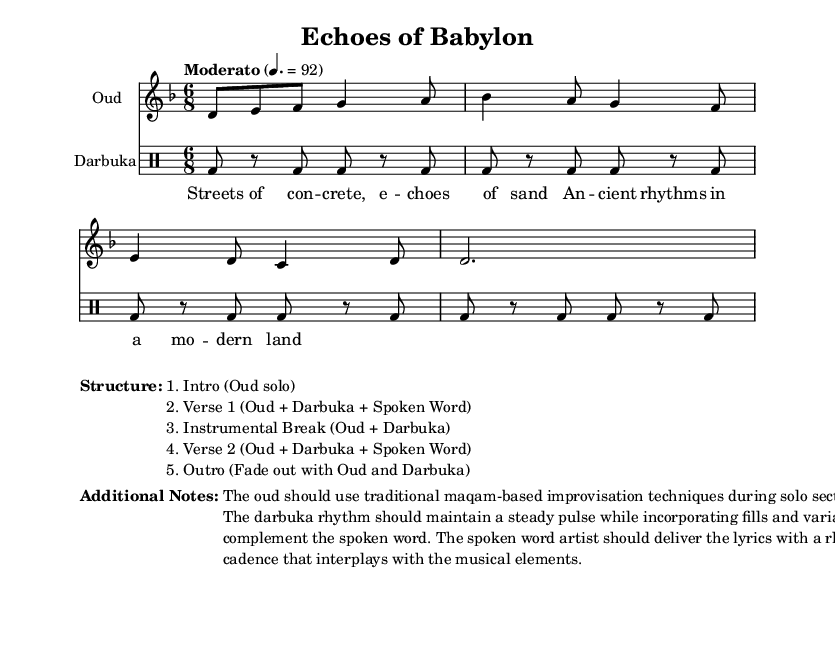What is the key signature of this music? The key signature shows 1 flat, indicating the presence of B flat, which is characteristic of D minor.
Answer: D minor What is the time signature of this music? The time signature is displayed prominently at the beginning of the score, indicating a 6/8 meter.
Answer: 6/8 What is the tempo marking for this piece? The tempo marking is "Moderato," which suggests a moderate pace, and is set at a specific metronome marking of 92 beats per minute.
Answer: Moderato, 92 How many sections are described in the structure? The structure is detailed in a list format within the markup section, revealing a total of five distinct sections.
Answer: 5 In which section does the spoken word occur? The spoken word is indicated to be performed in both Verse 1 and Verse 2, showing its integration with the music.
Answer: Verse 1 and Verse 2 What role does the oud play during the instrumental break? During the instrumental break, the oud continues to contribute with improvisation techniques based on traditional maqams, highlighting its importance in the composition.
Answer: Improvisation What type of rhythm is played by the darbuka? The darbuka employs a steady pulse while incorporating variations and fills, which is typical for its rhythmic style in this composition.
Answer: Steady pulse with variations 